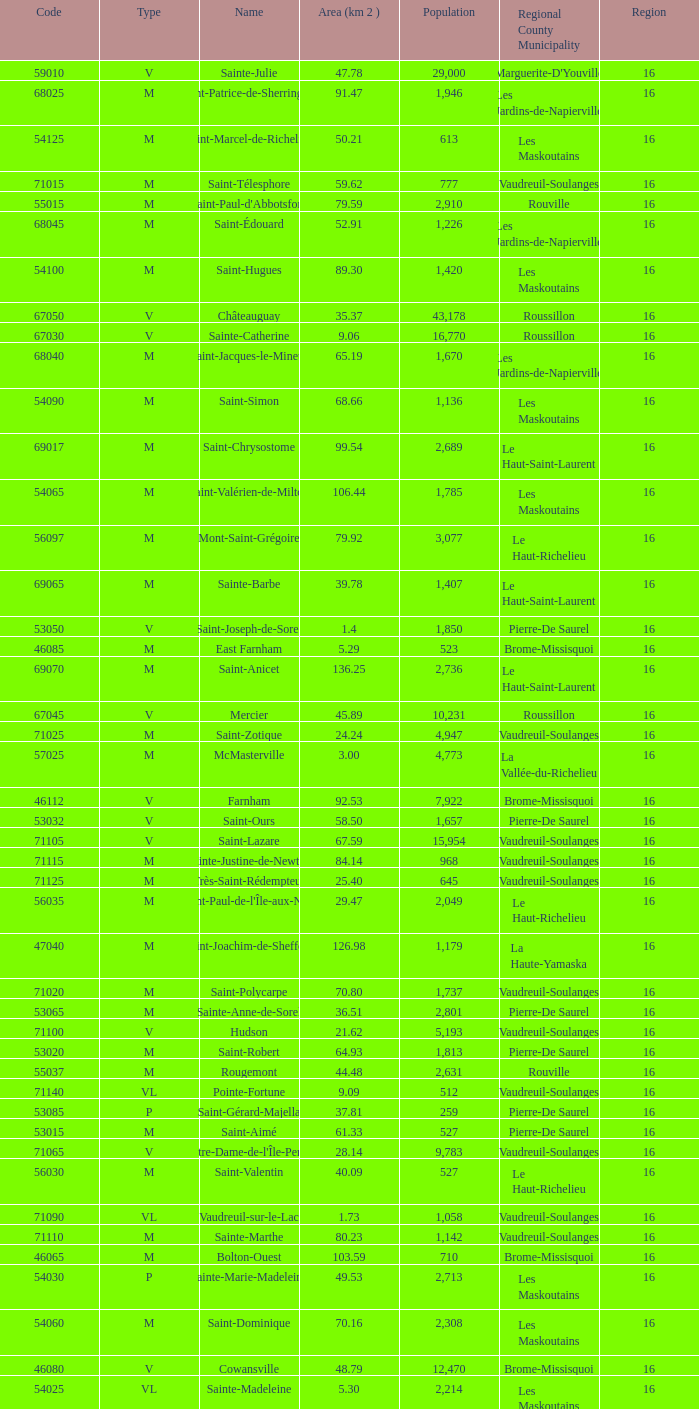Saint-Blaise-Sur-Richelieu is smaller than 68.42 km^2, what is the population of this type M municipality? None. 